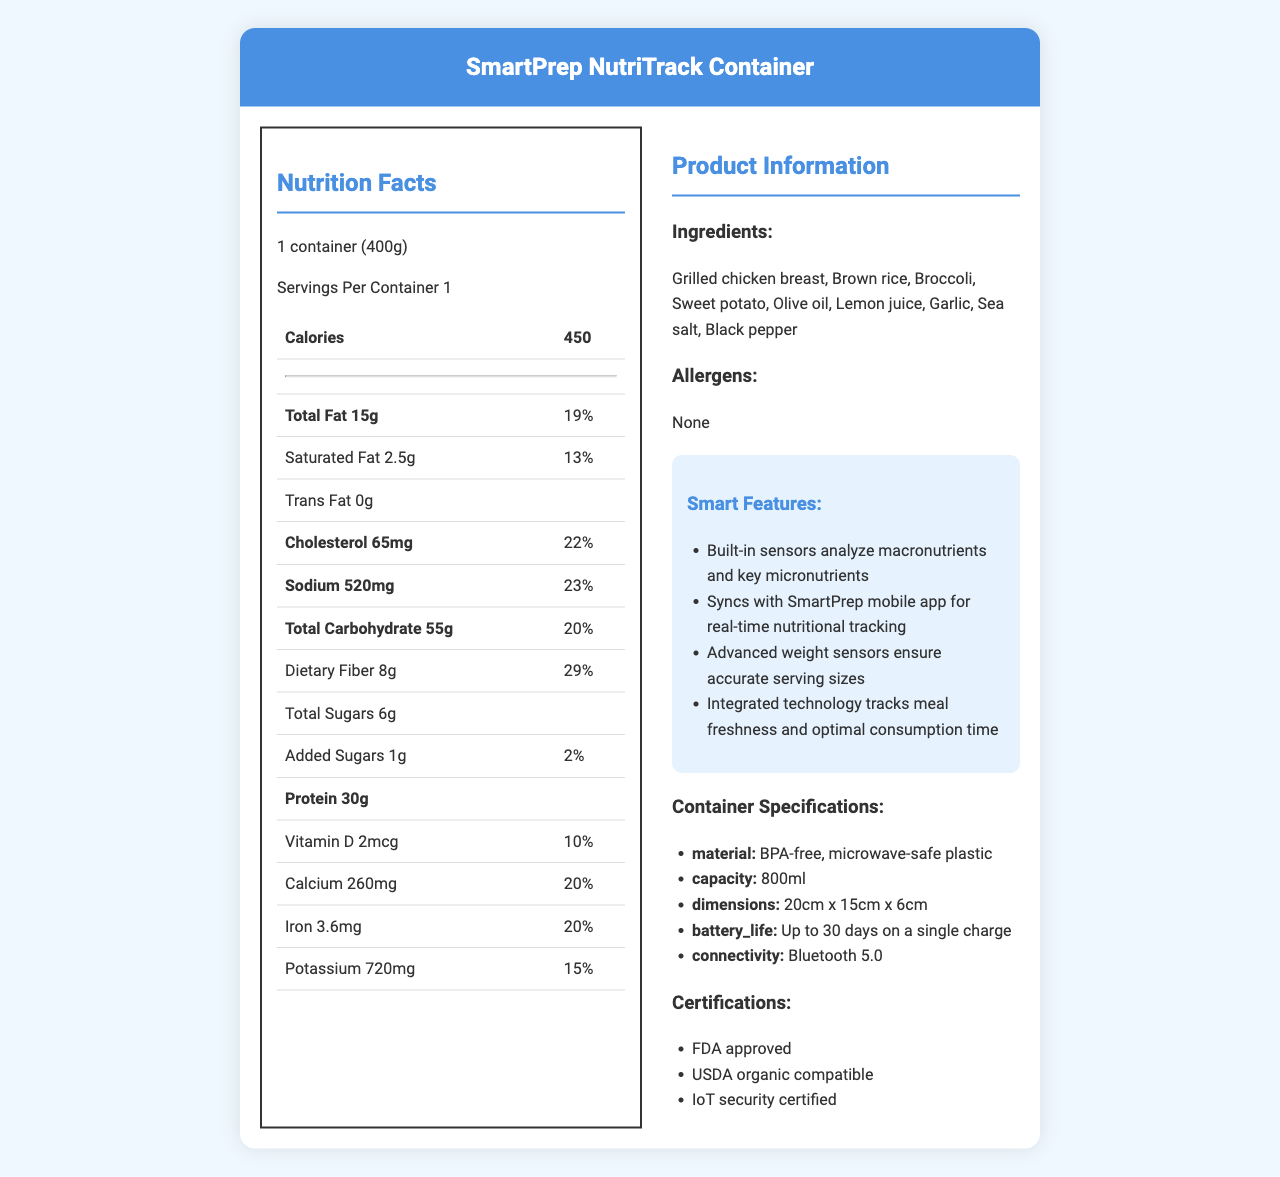what is the serving size for SmartPrep NutriTrack Container? The serving size is mentioned at the beginning of the Nutrition Facts section: serving size: 1 container (400g).
Answer: 1 container (400g) How many calories are in one serving of the SmartPrep NutriTrack Container? The number of calories per serving is listed in the table under Calories: 450.
Answer: 450 How much total fat is in one serving, and what is its daily value percentage? The Nutrition Facts indicate "Total Fat 15g" with a daily value of "19%."
Answer: 15g, 19% How much protein does one serving of the SmartPrep NutriTrack Container contain? The protein content per serving is listed as 30g in the Nutrition Facts.
Answer: 30g What are the primary ingredients in the SmartPrep NutriTrack Container? The ingredients list at the bottom of the Product Information section provides this information.
Answer: Grilled chicken breast, Brown rice, Broccoli, Sweet potato, Olive oil, Lemon juice, Garlic, Sea salt, Black pepper What are the smart features of the SmartPrep NutriTrack Container? The smart features are located in the Smart Features section and listed as bullet points.
Answer: Nutrient analysis, App integration, Portion control, Freshness monitor What certifications does the SmartPrep NutriTrack Container have? The certifications are listed in the Certifications section as bullet points.
Answer: FDA approved, USDA organic compatible, IoT security certified What is the sodium daily value percentage for one serving? A. 15% B. 20% C. 23% D. 25% The Nutrition Facts list the sodium content with a daily value of 23%.
Answer: C. 23% Which of the following features ensures accurate serving sizes? I. Nutrient Analysis II. Portion Control III. Freshness Monitor The portion control feature is the one that ensures accurate serving sizes, as indicated in the Smart Features section.
Answer: II. Portion Control Do the ingredients contain any allergens? The Allergens section clearly states "None."
Answer: No Could you summarize the main idea of the document? The document presents an advanced meal prep container with various smart features and detailed nutrition and product information, highlighting its functionality and health benefits.
Answer: The SmartPrep NutriTrack Container is a high-tech, FDA-approved meal prep container with built-in sensors for nutrient analysis, mobile app integration for real-time tracking, weight sensors for portion control, and technology for monitoring meal freshness. It includes a comprehensive nutrition facts label, detailing calories, macronutrients, micronutrients, and ingredients. What is the daily value percentage of dietary fiber per serving? The daily value percentage of dietary fiber is listed in the Nutrition Facts section: 29%.
Answer: 29% How long is the battery life of the SmartPrep NutriTrack Container? The battery life is specified in the Container Specifications section as "Up to 30 days on a single charge."
Answer: Up to 30 days on a single charge What material is the container made from? A. Glass B. Metal C. BPA-free plastic D. Wood The material is described in the Container Specifications section as "BPA-free, microwave-safe plastic."
Answer: C. BPA-free plastic What type of connectivity does the SmartPrep NutriTrack Container support? The Container Specifications section lists "Bluetooth 5.0" as the connectivity type.
Answer: Bluetooth 5.0 What is the price of the SmartPrep NutriTrack Container? The document does not provide any information about the price of the SmartPrep NutriTrack Container.
Answer: Cannot be determined 